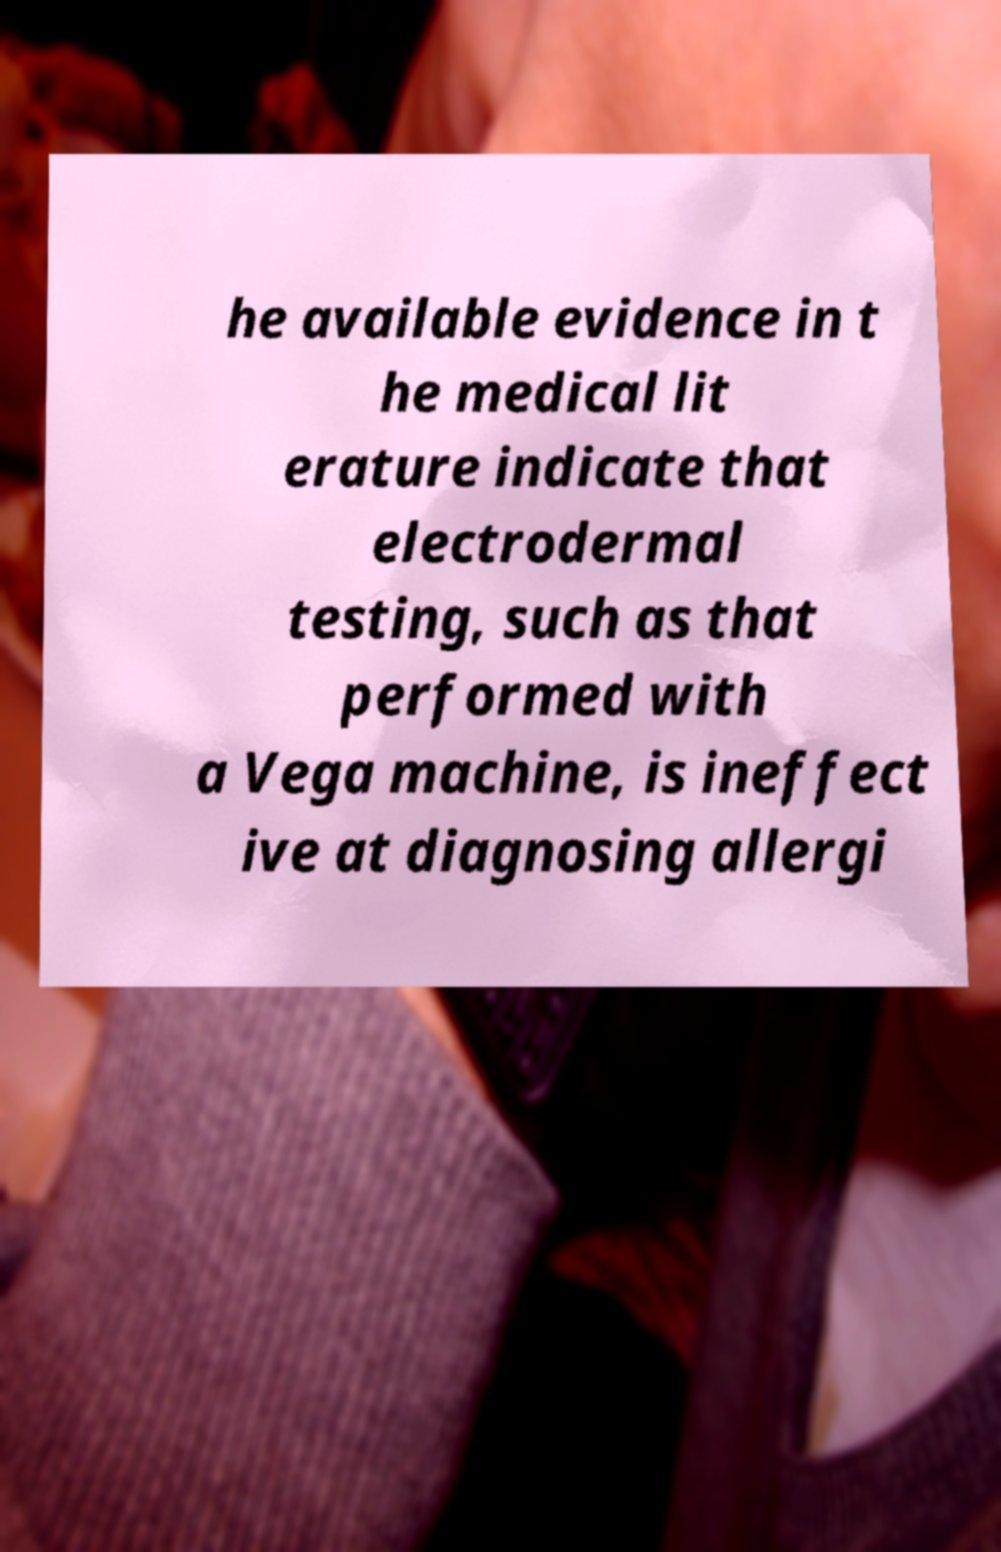Could you extract and type out the text from this image? he available evidence in t he medical lit erature indicate that electrodermal testing, such as that performed with a Vega machine, is ineffect ive at diagnosing allergi 